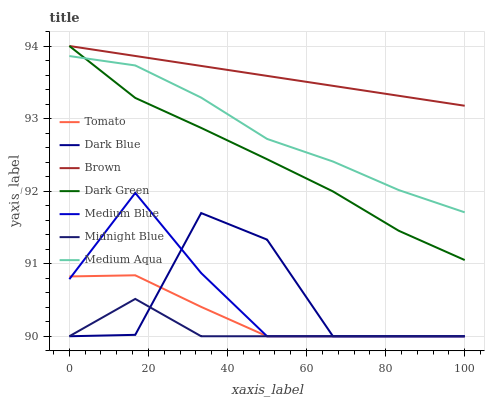Does Midnight Blue have the minimum area under the curve?
Answer yes or no. Yes. Does Brown have the maximum area under the curve?
Answer yes or no. Yes. Does Brown have the minimum area under the curve?
Answer yes or no. No. Does Midnight Blue have the maximum area under the curve?
Answer yes or no. No. Is Brown the smoothest?
Answer yes or no. Yes. Is Dark Blue the roughest?
Answer yes or no. Yes. Is Midnight Blue the smoothest?
Answer yes or no. No. Is Midnight Blue the roughest?
Answer yes or no. No. Does Tomato have the lowest value?
Answer yes or no. Yes. Does Brown have the lowest value?
Answer yes or no. No. Does Dark Green have the highest value?
Answer yes or no. Yes. Does Midnight Blue have the highest value?
Answer yes or no. No. Is Tomato less than Brown?
Answer yes or no. Yes. Is Dark Green greater than Tomato?
Answer yes or no. Yes. Does Tomato intersect Dark Blue?
Answer yes or no. Yes. Is Tomato less than Dark Blue?
Answer yes or no. No. Is Tomato greater than Dark Blue?
Answer yes or no. No. Does Tomato intersect Brown?
Answer yes or no. No. 